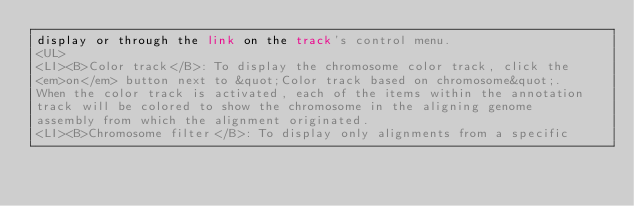Convert code to text. <code><loc_0><loc_0><loc_500><loc_500><_HTML_>display or through the link on the track's control menu.
<UL>
<LI><B>Color track</B>: To display the chromosome color track, click the
<em>on</em> button next to &quot;Color track based on chromosome&quot;.
When the color track is activated, each of the items within the annotation
track will be colored to show the chromosome in the aligning genome
assembly from which the alignment originated.
<LI><B>Chromosome filter</B>: To display only alignments from a specific</code> 